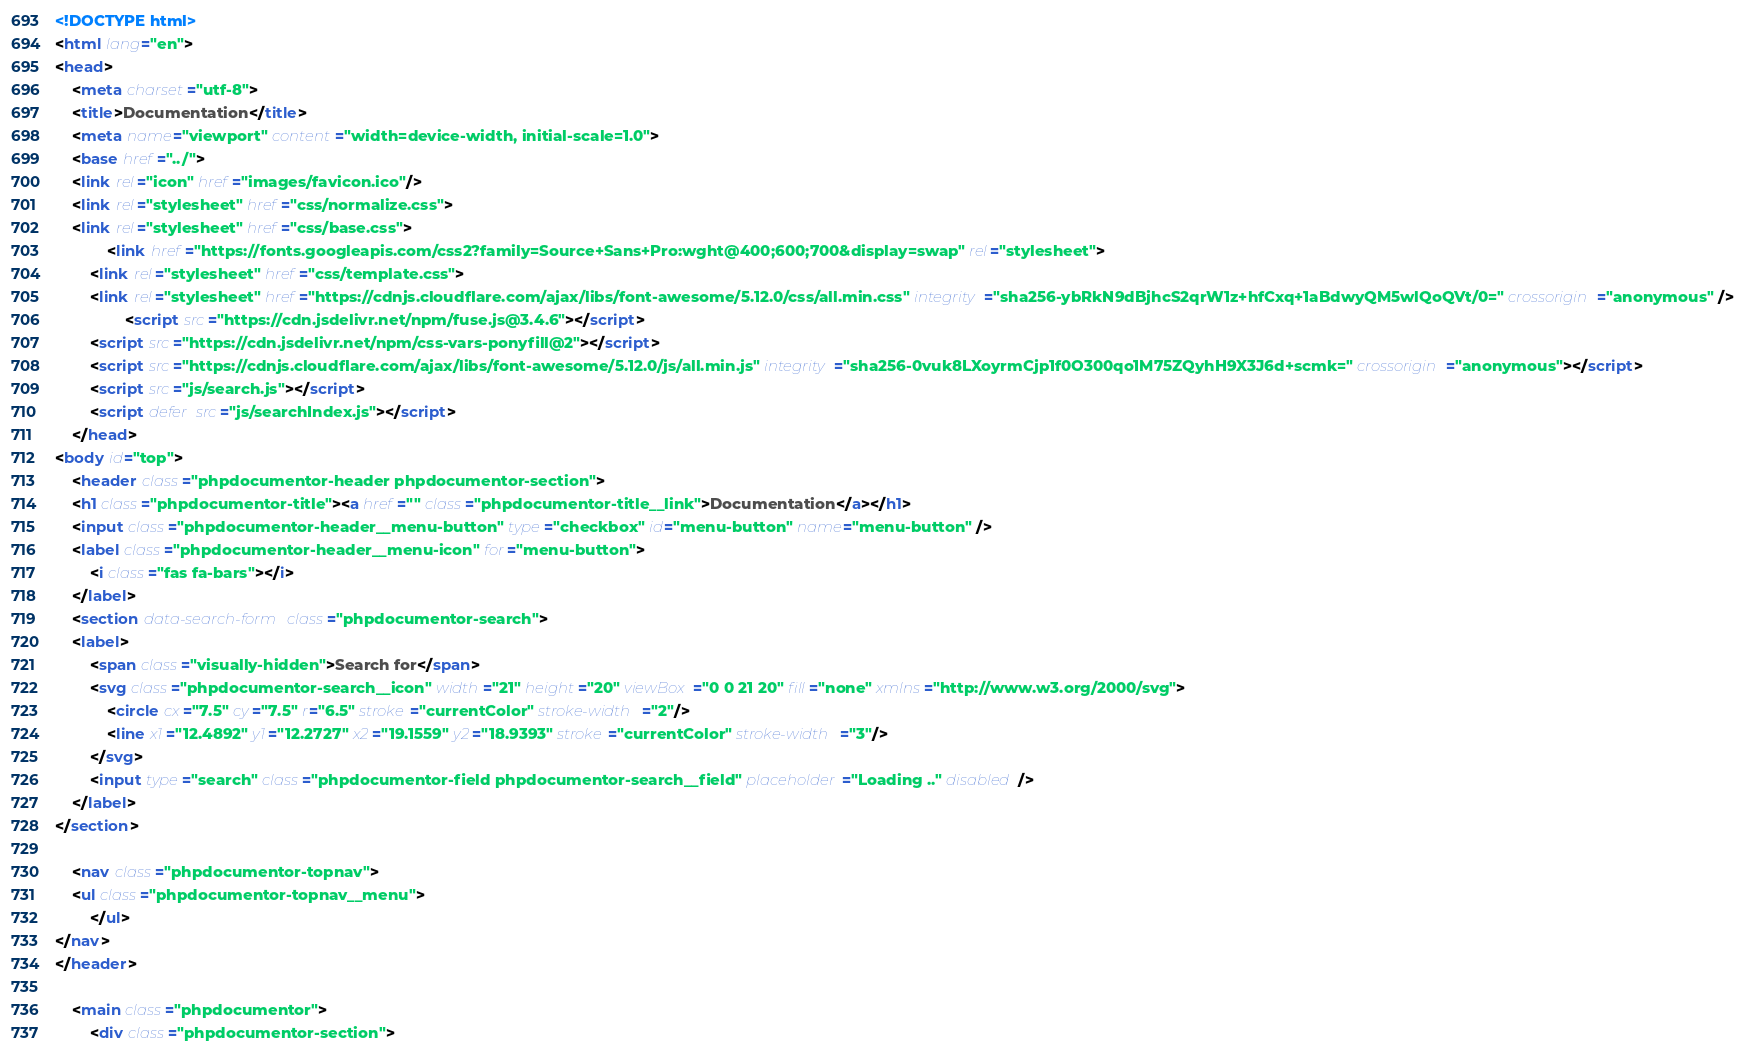Convert code to text. <code><loc_0><loc_0><loc_500><loc_500><_HTML_><!DOCTYPE html>
<html lang="en">
<head>
    <meta charset="utf-8">
    <title>Documentation</title>
    <meta name="viewport" content="width=device-width, initial-scale=1.0">
    <base href="../">
    <link rel="icon" href="images/favicon.ico"/>
    <link rel="stylesheet" href="css/normalize.css">
    <link rel="stylesheet" href="css/base.css">
            <link href="https://fonts.googleapis.com/css2?family=Source+Sans+Pro:wght@400;600;700&display=swap" rel="stylesheet">
        <link rel="stylesheet" href="css/template.css">
        <link rel="stylesheet" href="https://cdnjs.cloudflare.com/ajax/libs/font-awesome/5.12.0/css/all.min.css" integrity="sha256-ybRkN9dBjhcS2qrW1z+hfCxq+1aBdwyQM5wlQoQVt/0=" crossorigin="anonymous" />
                <script src="https://cdn.jsdelivr.net/npm/fuse.js@3.4.6"></script>
        <script src="https://cdn.jsdelivr.net/npm/css-vars-ponyfill@2"></script>
        <script src="https://cdnjs.cloudflare.com/ajax/libs/font-awesome/5.12.0/js/all.min.js" integrity="sha256-0vuk8LXoyrmCjp1f0O300qo1M75ZQyhH9X3J6d+scmk=" crossorigin="anonymous"></script>
        <script src="js/search.js"></script>
        <script defer src="js/searchIndex.js"></script>
    </head>
<body id="top">
    <header class="phpdocumentor-header phpdocumentor-section">
    <h1 class="phpdocumentor-title"><a href="" class="phpdocumentor-title__link">Documentation</a></h1>
    <input class="phpdocumentor-header__menu-button" type="checkbox" id="menu-button" name="menu-button" />
    <label class="phpdocumentor-header__menu-icon" for="menu-button">
        <i class="fas fa-bars"></i>
    </label>
    <section data-search-form class="phpdocumentor-search">
    <label>
        <span class="visually-hidden">Search for</span>
        <svg class="phpdocumentor-search__icon" width="21" height="20" viewBox="0 0 21 20" fill="none" xmlns="http://www.w3.org/2000/svg">
            <circle cx="7.5" cy="7.5" r="6.5" stroke="currentColor" stroke-width="2"/>
            <line x1="12.4892" y1="12.2727" x2="19.1559" y2="18.9393" stroke="currentColor" stroke-width="3"/>
        </svg>
        <input type="search" class="phpdocumentor-field phpdocumentor-search__field" placeholder="Loading .." disabled />
    </label>
</section>

    <nav class="phpdocumentor-topnav">
    <ul class="phpdocumentor-topnav__menu">
        </ul>
</nav>
</header>

    <main class="phpdocumentor">
        <div class="phpdocumentor-section"></code> 